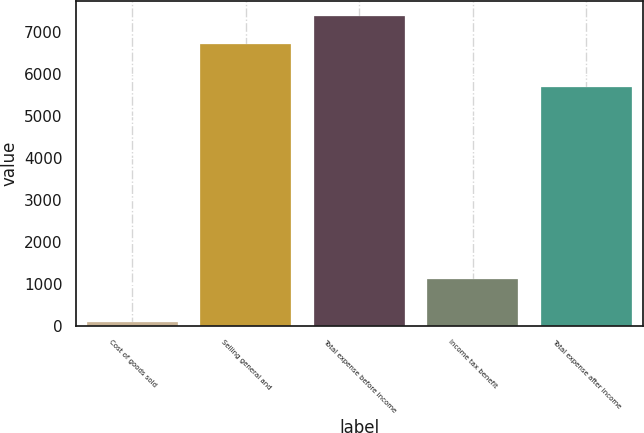<chart> <loc_0><loc_0><loc_500><loc_500><bar_chart><fcel>Cost of goods sold<fcel>Selling general and<fcel>Total expense before income<fcel>Income tax benefit<fcel>Total expense after income<nl><fcel>79<fcel>6717<fcel>7388.7<fcel>1108<fcel>5688<nl></chart> 